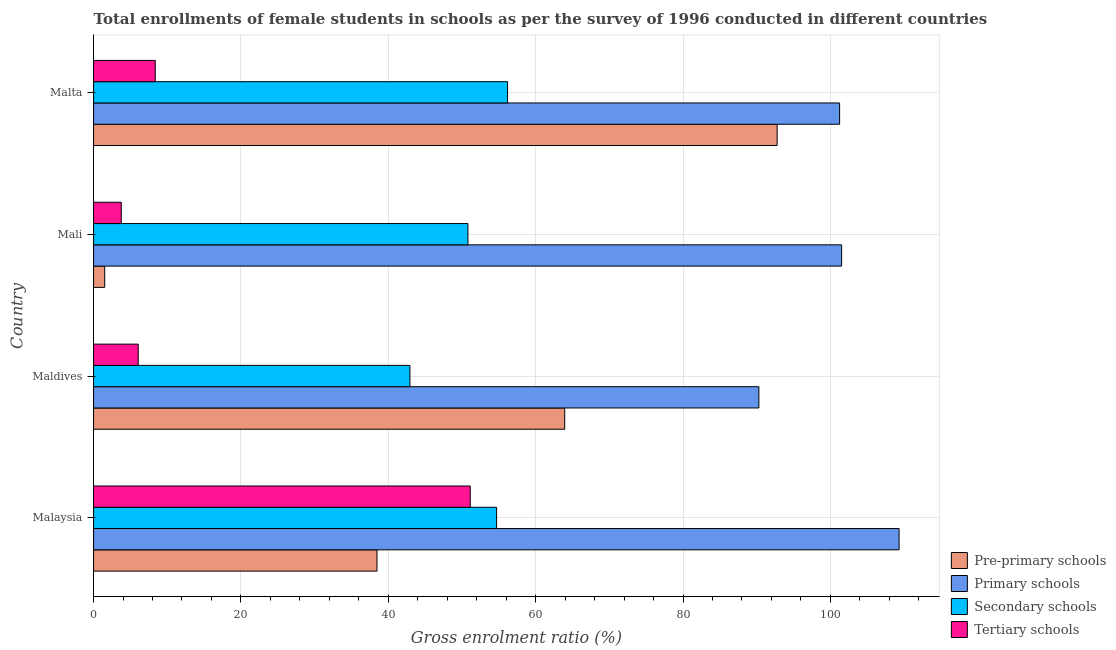How many different coloured bars are there?
Your answer should be very brief. 4. How many bars are there on the 1st tick from the top?
Offer a very short reply. 4. How many bars are there on the 4th tick from the bottom?
Provide a short and direct response. 4. What is the label of the 4th group of bars from the top?
Provide a succinct answer. Malaysia. What is the gross enrolment ratio(female) in pre-primary schools in Mali?
Provide a short and direct response. 1.51. Across all countries, what is the maximum gross enrolment ratio(female) in tertiary schools?
Provide a short and direct response. 51.12. Across all countries, what is the minimum gross enrolment ratio(female) in pre-primary schools?
Keep it short and to the point. 1.51. In which country was the gross enrolment ratio(female) in secondary schools maximum?
Keep it short and to the point. Malta. In which country was the gross enrolment ratio(female) in tertiary schools minimum?
Your answer should be very brief. Mali. What is the total gross enrolment ratio(female) in tertiary schools in the graph?
Offer a terse response. 69.31. What is the difference between the gross enrolment ratio(female) in primary schools in Malaysia and that in Mali?
Your answer should be very brief. 7.8. What is the difference between the gross enrolment ratio(female) in pre-primary schools in Mali and the gross enrolment ratio(female) in tertiary schools in Malaysia?
Your answer should be compact. -49.61. What is the average gross enrolment ratio(female) in tertiary schools per country?
Provide a short and direct response. 17.33. What is the difference between the gross enrolment ratio(female) in primary schools and gross enrolment ratio(female) in secondary schools in Mali?
Provide a succinct answer. 50.71. What is the ratio of the gross enrolment ratio(female) in primary schools in Mali to that in Malta?
Offer a very short reply. 1. Is the gross enrolment ratio(female) in secondary schools in Maldives less than that in Mali?
Your answer should be compact. Yes. What is the difference between the highest and the second highest gross enrolment ratio(female) in pre-primary schools?
Your answer should be very brief. 28.83. What is the difference between the highest and the lowest gross enrolment ratio(female) in primary schools?
Provide a short and direct response. 19.03. In how many countries, is the gross enrolment ratio(female) in primary schools greater than the average gross enrolment ratio(female) in primary schools taken over all countries?
Your answer should be compact. 3. Is the sum of the gross enrolment ratio(female) in pre-primary schools in Maldives and Malta greater than the maximum gross enrolment ratio(female) in secondary schools across all countries?
Offer a terse response. Yes. What does the 2nd bar from the top in Malaysia represents?
Provide a succinct answer. Secondary schools. What does the 4th bar from the bottom in Maldives represents?
Your answer should be very brief. Tertiary schools. How many bars are there?
Give a very brief answer. 16. Are all the bars in the graph horizontal?
Keep it short and to the point. Yes. What is the difference between two consecutive major ticks on the X-axis?
Provide a short and direct response. 20. Are the values on the major ticks of X-axis written in scientific E-notation?
Your response must be concise. No. Does the graph contain any zero values?
Keep it short and to the point. No. How many legend labels are there?
Ensure brevity in your answer.  4. How are the legend labels stacked?
Ensure brevity in your answer.  Vertical. What is the title of the graph?
Offer a very short reply. Total enrollments of female students in schools as per the survey of 1996 conducted in different countries. What is the label or title of the X-axis?
Ensure brevity in your answer.  Gross enrolment ratio (%). What is the label or title of the Y-axis?
Keep it short and to the point. Country. What is the Gross enrolment ratio (%) in Pre-primary schools in Malaysia?
Make the answer very short. 38.47. What is the Gross enrolment ratio (%) in Primary schools in Malaysia?
Your response must be concise. 109.32. What is the Gross enrolment ratio (%) of Secondary schools in Malaysia?
Your answer should be compact. 54.7. What is the Gross enrolment ratio (%) in Tertiary schools in Malaysia?
Offer a very short reply. 51.12. What is the Gross enrolment ratio (%) in Pre-primary schools in Maldives?
Make the answer very short. 63.94. What is the Gross enrolment ratio (%) of Primary schools in Maldives?
Make the answer very short. 90.29. What is the Gross enrolment ratio (%) of Secondary schools in Maldives?
Make the answer very short. 42.93. What is the Gross enrolment ratio (%) of Tertiary schools in Maldives?
Provide a short and direct response. 6.06. What is the Gross enrolment ratio (%) of Pre-primary schools in Mali?
Your answer should be very brief. 1.51. What is the Gross enrolment ratio (%) in Primary schools in Mali?
Offer a very short reply. 101.52. What is the Gross enrolment ratio (%) of Secondary schools in Mali?
Provide a short and direct response. 50.81. What is the Gross enrolment ratio (%) of Tertiary schools in Mali?
Offer a terse response. 3.76. What is the Gross enrolment ratio (%) of Pre-primary schools in Malta?
Offer a very short reply. 92.77. What is the Gross enrolment ratio (%) in Primary schools in Malta?
Keep it short and to the point. 101.25. What is the Gross enrolment ratio (%) of Secondary schools in Malta?
Provide a succinct answer. 56.18. What is the Gross enrolment ratio (%) in Tertiary schools in Malta?
Give a very brief answer. 8.38. Across all countries, what is the maximum Gross enrolment ratio (%) of Pre-primary schools?
Keep it short and to the point. 92.77. Across all countries, what is the maximum Gross enrolment ratio (%) in Primary schools?
Provide a succinct answer. 109.32. Across all countries, what is the maximum Gross enrolment ratio (%) in Secondary schools?
Offer a terse response. 56.18. Across all countries, what is the maximum Gross enrolment ratio (%) of Tertiary schools?
Your answer should be very brief. 51.12. Across all countries, what is the minimum Gross enrolment ratio (%) of Pre-primary schools?
Ensure brevity in your answer.  1.51. Across all countries, what is the minimum Gross enrolment ratio (%) in Primary schools?
Give a very brief answer. 90.29. Across all countries, what is the minimum Gross enrolment ratio (%) in Secondary schools?
Provide a succinct answer. 42.93. Across all countries, what is the minimum Gross enrolment ratio (%) of Tertiary schools?
Keep it short and to the point. 3.76. What is the total Gross enrolment ratio (%) of Pre-primary schools in the graph?
Your response must be concise. 196.69. What is the total Gross enrolment ratio (%) of Primary schools in the graph?
Ensure brevity in your answer.  402.38. What is the total Gross enrolment ratio (%) of Secondary schools in the graph?
Your response must be concise. 204.63. What is the total Gross enrolment ratio (%) in Tertiary schools in the graph?
Give a very brief answer. 69.31. What is the difference between the Gross enrolment ratio (%) in Pre-primary schools in Malaysia and that in Maldives?
Your answer should be compact. -25.48. What is the difference between the Gross enrolment ratio (%) in Primary schools in Malaysia and that in Maldives?
Offer a terse response. 19.03. What is the difference between the Gross enrolment ratio (%) of Secondary schools in Malaysia and that in Maldives?
Give a very brief answer. 11.77. What is the difference between the Gross enrolment ratio (%) of Tertiary schools in Malaysia and that in Maldives?
Offer a terse response. 45.06. What is the difference between the Gross enrolment ratio (%) of Pre-primary schools in Malaysia and that in Mali?
Your answer should be very brief. 36.95. What is the difference between the Gross enrolment ratio (%) of Primary schools in Malaysia and that in Mali?
Your response must be concise. 7.8. What is the difference between the Gross enrolment ratio (%) in Secondary schools in Malaysia and that in Mali?
Provide a succinct answer. 3.89. What is the difference between the Gross enrolment ratio (%) of Tertiary schools in Malaysia and that in Mali?
Offer a very short reply. 47.36. What is the difference between the Gross enrolment ratio (%) of Pre-primary schools in Malaysia and that in Malta?
Your answer should be very brief. -54.3. What is the difference between the Gross enrolment ratio (%) in Primary schools in Malaysia and that in Malta?
Your answer should be very brief. 8.07. What is the difference between the Gross enrolment ratio (%) of Secondary schools in Malaysia and that in Malta?
Provide a succinct answer. -1.48. What is the difference between the Gross enrolment ratio (%) of Tertiary schools in Malaysia and that in Malta?
Provide a short and direct response. 42.74. What is the difference between the Gross enrolment ratio (%) in Pre-primary schools in Maldives and that in Mali?
Your response must be concise. 62.43. What is the difference between the Gross enrolment ratio (%) in Primary schools in Maldives and that in Mali?
Your response must be concise. -11.23. What is the difference between the Gross enrolment ratio (%) of Secondary schools in Maldives and that in Mali?
Provide a short and direct response. -7.87. What is the difference between the Gross enrolment ratio (%) of Tertiary schools in Maldives and that in Mali?
Your answer should be very brief. 2.3. What is the difference between the Gross enrolment ratio (%) in Pre-primary schools in Maldives and that in Malta?
Offer a terse response. -28.83. What is the difference between the Gross enrolment ratio (%) in Primary schools in Maldives and that in Malta?
Make the answer very short. -10.96. What is the difference between the Gross enrolment ratio (%) in Secondary schools in Maldives and that in Malta?
Your response must be concise. -13.25. What is the difference between the Gross enrolment ratio (%) of Tertiary schools in Maldives and that in Malta?
Keep it short and to the point. -2.32. What is the difference between the Gross enrolment ratio (%) of Pre-primary schools in Mali and that in Malta?
Give a very brief answer. -91.26. What is the difference between the Gross enrolment ratio (%) of Primary schools in Mali and that in Malta?
Your answer should be very brief. 0.27. What is the difference between the Gross enrolment ratio (%) in Secondary schools in Mali and that in Malta?
Give a very brief answer. -5.38. What is the difference between the Gross enrolment ratio (%) of Tertiary schools in Mali and that in Malta?
Your answer should be very brief. -4.62. What is the difference between the Gross enrolment ratio (%) of Pre-primary schools in Malaysia and the Gross enrolment ratio (%) of Primary schools in Maldives?
Give a very brief answer. -51.83. What is the difference between the Gross enrolment ratio (%) in Pre-primary schools in Malaysia and the Gross enrolment ratio (%) in Secondary schools in Maldives?
Your response must be concise. -4.47. What is the difference between the Gross enrolment ratio (%) in Pre-primary schools in Malaysia and the Gross enrolment ratio (%) in Tertiary schools in Maldives?
Provide a succinct answer. 32.41. What is the difference between the Gross enrolment ratio (%) in Primary schools in Malaysia and the Gross enrolment ratio (%) in Secondary schools in Maldives?
Provide a short and direct response. 66.39. What is the difference between the Gross enrolment ratio (%) in Primary schools in Malaysia and the Gross enrolment ratio (%) in Tertiary schools in Maldives?
Make the answer very short. 103.26. What is the difference between the Gross enrolment ratio (%) of Secondary schools in Malaysia and the Gross enrolment ratio (%) of Tertiary schools in Maldives?
Provide a succinct answer. 48.64. What is the difference between the Gross enrolment ratio (%) in Pre-primary schools in Malaysia and the Gross enrolment ratio (%) in Primary schools in Mali?
Provide a succinct answer. -63.05. What is the difference between the Gross enrolment ratio (%) of Pre-primary schools in Malaysia and the Gross enrolment ratio (%) of Secondary schools in Mali?
Ensure brevity in your answer.  -12.34. What is the difference between the Gross enrolment ratio (%) in Pre-primary schools in Malaysia and the Gross enrolment ratio (%) in Tertiary schools in Mali?
Give a very brief answer. 34.71. What is the difference between the Gross enrolment ratio (%) in Primary schools in Malaysia and the Gross enrolment ratio (%) in Secondary schools in Mali?
Give a very brief answer. 58.51. What is the difference between the Gross enrolment ratio (%) in Primary schools in Malaysia and the Gross enrolment ratio (%) in Tertiary schools in Mali?
Keep it short and to the point. 105.56. What is the difference between the Gross enrolment ratio (%) in Secondary schools in Malaysia and the Gross enrolment ratio (%) in Tertiary schools in Mali?
Make the answer very short. 50.94. What is the difference between the Gross enrolment ratio (%) in Pre-primary schools in Malaysia and the Gross enrolment ratio (%) in Primary schools in Malta?
Offer a terse response. -62.78. What is the difference between the Gross enrolment ratio (%) in Pre-primary schools in Malaysia and the Gross enrolment ratio (%) in Secondary schools in Malta?
Offer a terse response. -17.72. What is the difference between the Gross enrolment ratio (%) of Pre-primary schools in Malaysia and the Gross enrolment ratio (%) of Tertiary schools in Malta?
Your answer should be compact. 30.09. What is the difference between the Gross enrolment ratio (%) of Primary schools in Malaysia and the Gross enrolment ratio (%) of Secondary schools in Malta?
Give a very brief answer. 53.13. What is the difference between the Gross enrolment ratio (%) of Primary schools in Malaysia and the Gross enrolment ratio (%) of Tertiary schools in Malta?
Offer a very short reply. 100.94. What is the difference between the Gross enrolment ratio (%) of Secondary schools in Malaysia and the Gross enrolment ratio (%) of Tertiary schools in Malta?
Ensure brevity in your answer.  46.32. What is the difference between the Gross enrolment ratio (%) in Pre-primary schools in Maldives and the Gross enrolment ratio (%) in Primary schools in Mali?
Give a very brief answer. -37.58. What is the difference between the Gross enrolment ratio (%) of Pre-primary schools in Maldives and the Gross enrolment ratio (%) of Secondary schools in Mali?
Your answer should be compact. 13.13. What is the difference between the Gross enrolment ratio (%) of Pre-primary schools in Maldives and the Gross enrolment ratio (%) of Tertiary schools in Mali?
Your response must be concise. 60.18. What is the difference between the Gross enrolment ratio (%) in Primary schools in Maldives and the Gross enrolment ratio (%) in Secondary schools in Mali?
Your answer should be very brief. 39.48. What is the difference between the Gross enrolment ratio (%) of Primary schools in Maldives and the Gross enrolment ratio (%) of Tertiary schools in Mali?
Keep it short and to the point. 86.53. What is the difference between the Gross enrolment ratio (%) in Secondary schools in Maldives and the Gross enrolment ratio (%) in Tertiary schools in Mali?
Your answer should be compact. 39.17. What is the difference between the Gross enrolment ratio (%) of Pre-primary schools in Maldives and the Gross enrolment ratio (%) of Primary schools in Malta?
Make the answer very short. -37.31. What is the difference between the Gross enrolment ratio (%) in Pre-primary schools in Maldives and the Gross enrolment ratio (%) in Secondary schools in Malta?
Your response must be concise. 7.76. What is the difference between the Gross enrolment ratio (%) of Pre-primary schools in Maldives and the Gross enrolment ratio (%) of Tertiary schools in Malta?
Keep it short and to the point. 55.57. What is the difference between the Gross enrolment ratio (%) of Primary schools in Maldives and the Gross enrolment ratio (%) of Secondary schools in Malta?
Keep it short and to the point. 34.11. What is the difference between the Gross enrolment ratio (%) of Primary schools in Maldives and the Gross enrolment ratio (%) of Tertiary schools in Malta?
Ensure brevity in your answer.  81.92. What is the difference between the Gross enrolment ratio (%) of Secondary schools in Maldives and the Gross enrolment ratio (%) of Tertiary schools in Malta?
Your response must be concise. 34.56. What is the difference between the Gross enrolment ratio (%) of Pre-primary schools in Mali and the Gross enrolment ratio (%) of Primary schools in Malta?
Give a very brief answer. -99.74. What is the difference between the Gross enrolment ratio (%) of Pre-primary schools in Mali and the Gross enrolment ratio (%) of Secondary schools in Malta?
Your answer should be compact. -54.67. What is the difference between the Gross enrolment ratio (%) of Pre-primary schools in Mali and the Gross enrolment ratio (%) of Tertiary schools in Malta?
Your answer should be very brief. -6.86. What is the difference between the Gross enrolment ratio (%) in Primary schools in Mali and the Gross enrolment ratio (%) in Secondary schools in Malta?
Keep it short and to the point. 45.34. What is the difference between the Gross enrolment ratio (%) of Primary schools in Mali and the Gross enrolment ratio (%) of Tertiary schools in Malta?
Your answer should be compact. 93.15. What is the difference between the Gross enrolment ratio (%) of Secondary schools in Mali and the Gross enrolment ratio (%) of Tertiary schools in Malta?
Provide a succinct answer. 42.43. What is the average Gross enrolment ratio (%) in Pre-primary schools per country?
Provide a short and direct response. 49.17. What is the average Gross enrolment ratio (%) in Primary schools per country?
Your answer should be very brief. 100.6. What is the average Gross enrolment ratio (%) in Secondary schools per country?
Keep it short and to the point. 51.16. What is the average Gross enrolment ratio (%) of Tertiary schools per country?
Give a very brief answer. 17.33. What is the difference between the Gross enrolment ratio (%) of Pre-primary schools and Gross enrolment ratio (%) of Primary schools in Malaysia?
Provide a short and direct response. -70.85. What is the difference between the Gross enrolment ratio (%) in Pre-primary schools and Gross enrolment ratio (%) in Secondary schools in Malaysia?
Offer a terse response. -16.23. What is the difference between the Gross enrolment ratio (%) of Pre-primary schools and Gross enrolment ratio (%) of Tertiary schools in Malaysia?
Make the answer very short. -12.65. What is the difference between the Gross enrolment ratio (%) of Primary schools and Gross enrolment ratio (%) of Secondary schools in Malaysia?
Give a very brief answer. 54.62. What is the difference between the Gross enrolment ratio (%) in Primary schools and Gross enrolment ratio (%) in Tertiary schools in Malaysia?
Keep it short and to the point. 58.2. What is the difference between the Gross enrolment ratio (%) of Secondary schools and Gross enrolment ratio (%) of Tertiary schools in Malaysia?
Provide a short and direct response. 3.58. What is the difference between the Gross enrolment ratio (%) in Pre-primary schools and Gross enrolment ratio (%) in Primary schools in Maldives?
Your answer should be very brief. -26.35. What is the difference between the Gross enrolment ratio (%) of Pre-primary schools and Gross enrolment ratio (%) of Secondary schools in Maldives?
Your answer should be very brief. 21.01. What is the difference between the Gross enrolment ratio (%) of Pre-primary schools and Gross enrolment ratio (%) of Tertiary schools in Maldives?
Offer a very short reply. 57.88. What is the difference between the Gross enrolment ratio (%) of Primary schools and Gross enrolment ratio (%) of Secondary schools in Maldives?
Offer a terse response. 47.36. What is the difference between the Gross enrolment ratio (%) in Primary schools and Gross enrolment ratio (%) in Tertiary schools in Maldives?
Offer a very short reply. 84.23. What is the difference between the Gross enrolment ratio (%) of Secondary schools and Gross enrolment ratio (%) of Tertiary schools in Maldives?
Offer a terse response. 36.87. What is the difference between the Gross enrolment ratio (%) of Pre-primary schools and Gross enrolment ratio (%) of Primary schools in Mali?
Offer a very short reply. -100.01. What is the difference between the Gross enrolment ratio (%) of Pre-primary schools and Gross enrolment ratio (%) of Secondary schools in Mali?
Offer a terse response. -49.3. What is the difference between the Gross enrolment ratio (%) in Pre-primary schools and Gross enrolment ratio (%) in Tertiary schools in Mali?
Make the answer very short. -2.25. What is the difference between the Gross enrolment ratio (%) of Primary schools and Gross enrolment ratio (%) of Secondary schools in Mali?
Keep it short and to the point. 50.71. What is the difference between the Gross enrolment ratio (%) in Primary schools and Gross enrolment ratio (%) in Tertiary schools in Mali?
Provide a succinct answer. 97.76. What is the difference between the Gross enrolment ratio (%) in Secondary schools and Gross enrolment ratio (%) in Tertiary schools in Mali?
Your answer should be very brief. 47.05. What is the difference between the Gross enrolment ratio (%) of Pre-primary schools and Gross enrolment ratio (%) of Primary schools in Malta?
Offer a very short reply. -8.48. What is the difference between the Gross enrolment ratio (%) in Pre-primary schools and Gross enrolment ratio (%) in Secondary schools in Malta?
Provide a succinct answer. 36.59. What is the difference between the Gross enrolment ratio (%) of Pre-primary schools and Gross enrolment ratio (%) of Tertiary schools in Malta?
Keep it short and to the point. 84.4. What is the difference between the Gross enrolment ratio (%) of Primary schools and Gross enrolment ratio (%) of Secondary schools in Malta?
Your response must be concise. 45.06. What is the difference between the Gross enrolment ratio (%) in Primary schools and Gross enrolment ratio (%) in Tertiary schools in Malta?
Ensure brevity in your answer.  92.87. What is the difference between the Gross enrolment ratio (%) in Secondary schools and Gross enrolment ratio (%) in Tertiary schools in Malta?
Your answer should be very brief. 47.81. What is the ratio of the Gross enrolment ratio (%) in Pre-primary schools in Malaysia to that in Maldives?
Offer a terse response. 0.6. What is the ratio of the Gross enrolment ratio (%) of Primary schools in Malaysia to that in Maldives?
Keep it short and to the point. 1.21. What is the ratio of the Gross enrolment ratio (%) of Secondary schools in Malaysia to that in Maldives?
Offer a very short reply. 1.27. What is the ratio of the Gross enrolment ratio (%) of Tertiary schools in Malaysia to that in Maldives?
Keep it short and to the point. 8.44. What is the ratio of the Gross enrolment ratio (%) of Pre-primary schools in Malaysia to that in Mali?
Your answer should be compact. 25.43. What is the ratio of the Gross enrolment ratio (%) in Primary schools in Malaysia to that in Mali?
Provide a succinct answer. 1.08. What is the ratio of the Gross enrolment ratio (%) of Secondary schools in Malaysia to that in Mali?
Offer a terse response. 1.08. What is the ratio of the Gross enrolment ratio (%) in Tertiary schools in Malaysia to that in Mali?
Make the answer very short. 13.59. What is the ratio of the Gross enrolment ratio (%) in Pre-primary schools in Malaysia to that in Malta?
Give a very brief answer. 0.41. What is the ratio of the Gross enrolment ratio (%) of Primary schools in Malaysia to that in Malta?
Your answer should be very brief. 1.08. What is the ratio of the Gross enrolment ratio (%) in Secondary schools in Malaysia to that in Malta?
Ensure brevity in your answer.  0.97. What is the ratio of the Gross enrolment ratio (%) of Tertiary schools in Malaysia to that in Malta?
Provide a short and direct response. 6.1. What is the ratio of the Gross enrolment ratio (%) in Pre-primary schools in Maldives to that in Mali?
Give a very brief answer. 42.27. What is the ratio of the Gross enrolment ratio (%) in Primary schools in Maldives to that in Mali?
Keep it short and to the point. 0.89. What is the ratio of the Gross enrolment ratio (%) in Secondary schools in Maldives to that in Mali?
Ensure brevity in your answer.  0.84. What is the ratio of the Gross enrolment ratio (%) in Tertiary schools in Maldives to that in Mali?
Provide a short and direct response. 1.61. What is the ratio of the Gross enrolment ratio (%) in Pre-primary schools in Maldives to that in Malta?
Your response must be concise. 0.69. What is the ratio of the Gross enrolment ratio (%) of Primary schools in Maldives to that in Malta?
Keep it short and to the point. 0.89. What is the ratio of the Gross enrolment ratio (%) in Secondary schools in Maldives to that in Malta?
Your answer should be compact. 0.76. What is the ratio of the Gross enrolment ratio (%) of Tertiary schools in Maldives to that in Malta?
Ensure brevity in your answer.  0.72. What is the ratio of the Gross enrolment ratio (%) in Pre-primary schools in Mali to that in Malta?
Provide a succinct answer. 0.02. What is the ratio of the Gross enrolment ratio (%) in Secondary schools in Mali to that in Malta?
Keep it short and to the point. 0.9. What is the ratio of the Gross enrolment ratio (%) in Tertiary schools in Mali to that in Malta?
Make the answer very short. 0.45. What is the difference between the highest and the second highest Gross enrolment ratio (%) in Pre-primary schools?
Provide a succinct answer. 28.83. What is the difference between the highest and the second highest Gross enrolment ratio (%) in Primary schools?
Keep it short and to the point. 7.8. What is the difference between the highest and the second highest Gross enrolment ratio (%) of Secondary schools?
Offer a terse response. 1.48. What is the difference between the highest and the second highest Gross enrolment ratio (%) of Tertiary schools?
Make the answer very short. 42.74. What is the difference between the highest and the lowest Gross enrolment ratio (%) in Pre-primary schools?
Your response must be concise. 91.26. What is the difference between the highest and the lowest Gross enrolment ratio (%) of Primary schools?
Your answer should be compact. 19.03. What is the difference between the highest and the lowest Gross enrolment ratio (%) of Secondary schools?
Make the answer very short. 13.25. What is the difference between the highest and the lowest Gross enrolment ratio (%) of Tertiary schools?
Your answer should be very brief. 47.36. 